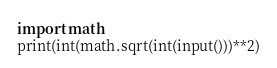Convert code to text. <code><loc_0><loc_0><loc_500><loc_500><_Python_>import math
print(int(math.sqrt(int(input()))**2)</code> 